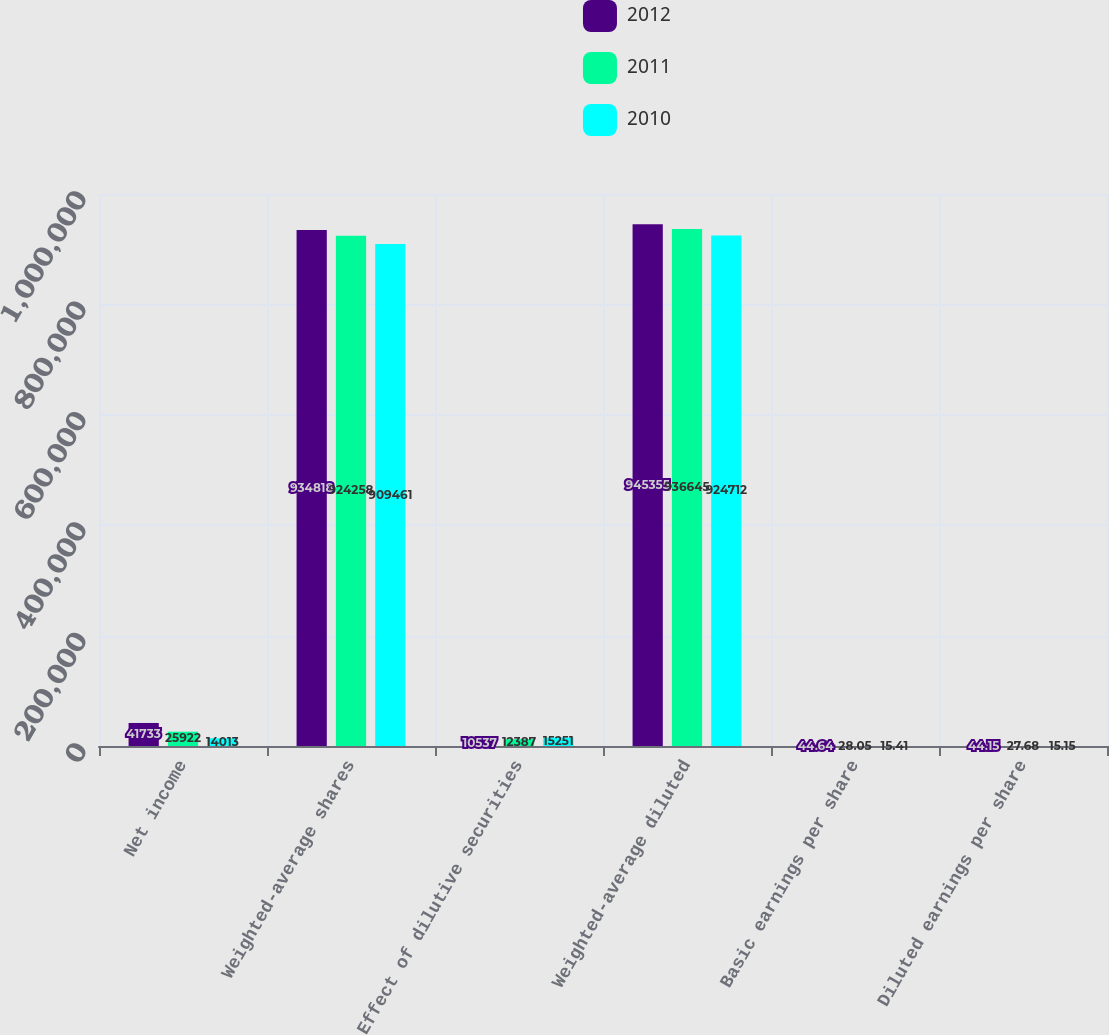Convert chart to OTSL. <chart><loc_0><loc_0><loc_500><loc_500><stacked_bar_chart><ecel><fcel>Net income<fcel>Weighted-average shares<fcel>Effect of dilutive securities<fcel>Weighted-average diluted<fcel>Basic earnings per share<fcel>Diluted earnings per share<nl><fcel>2012<fcel>41733<fcel>934818<fcel>10537<fcel>945355<fcel>44.64<fcel>44.15<nl><fcel>2011<fcel>25922<fcel>924258<fcel>12387<fcel>936645<fcel>28.05<fcel>27.68<nl><fcel>2010<fcel>14013<fcel>909461<fcel>15251<fcel>924712<fcel>15.41<fcel>15.15<nl></chart> 